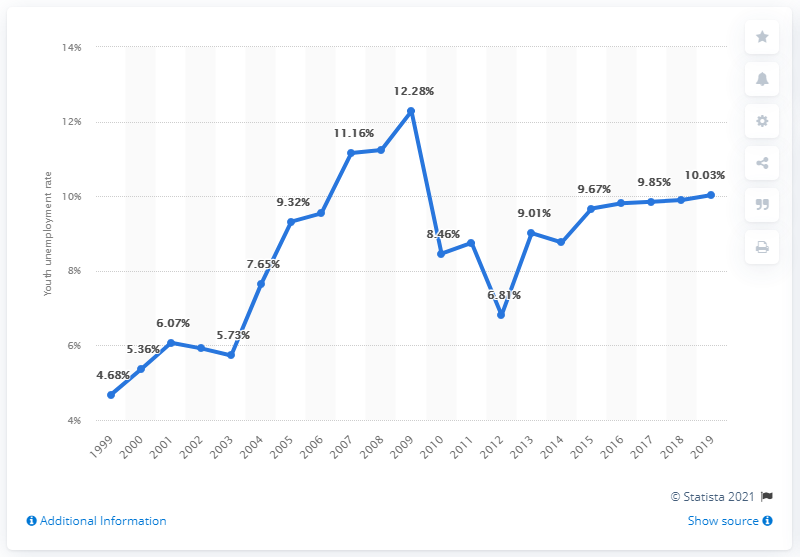Point out several critical features in this image. In 2019, the youth unemployment rate in Bhutan was 10.03%. 